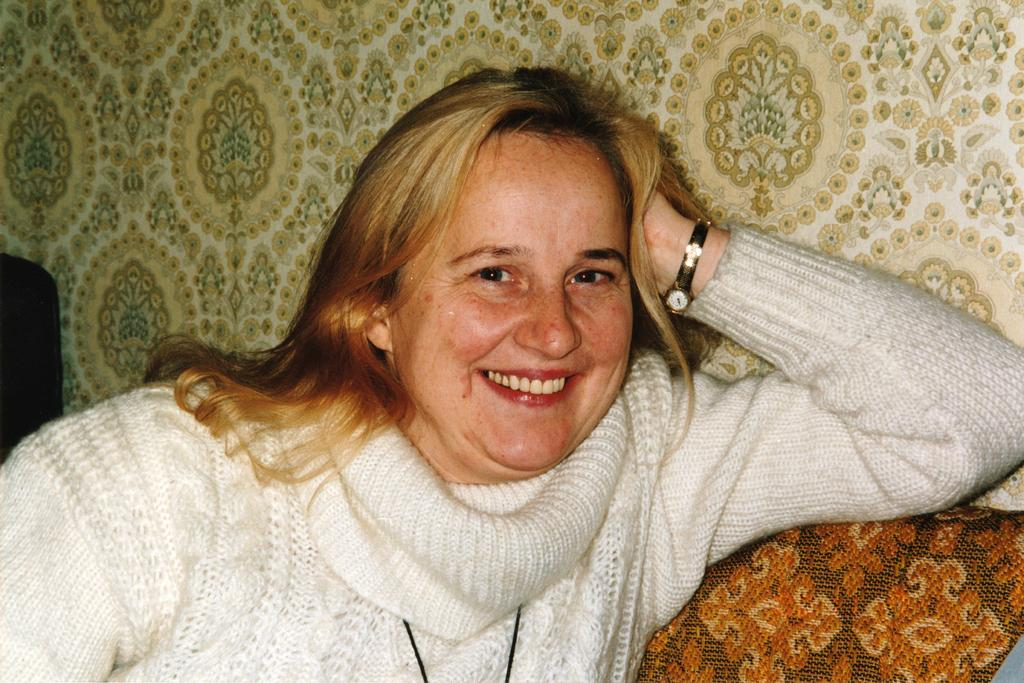What is the woman in the image doing? The woman is sitting in the image. What can be seen behind the woman in the image? There is a wall visible in the image. What is the woman learning about low-crush techniques in the image? There is no indication in the image that the woman is learning about low-crush techniques or any other specific topic. 